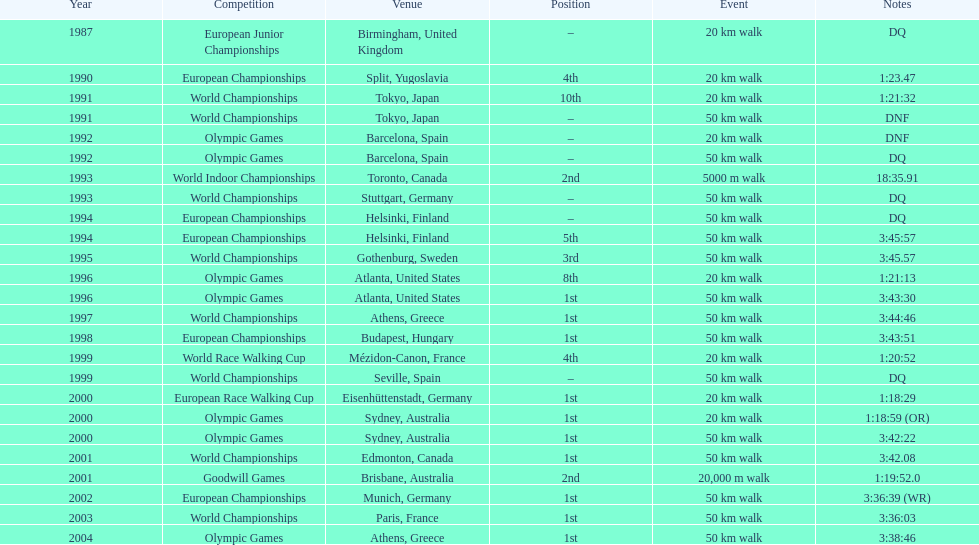Help me parse the entirety of this table. {'header': ['Year', 'Competition', 'Venue', 'Position', 'Event', 'Notes'], 'rows': [['1987', 'European Junior Championships', 'Birmingham, United Kingdom', '–', '20\xa0km walk', 'DQ'], ['1990', 'European Championships', 'Split, Yugoslavia', '4th', '20\xa0km walk', '1:23.47'], ['1991', 'World Championships', 'Tokyo, Japan', '10th', '20\xa0km walk', '1:21:32'], ['1991', 'World Championships', 'Tokyo, Japan', '–', '50\xa0km walk', 'DNF'], ['1992', 'Olympic Games', 'Barcelona, Spain', '–', '20\xa0km walk', 'DNF'], ['1992', 'Olympic Games', 'Barcelona, Spain', '–', '50\xa0km walk', 'DQ'], ['1993', 'World Indoor Championships', 'Toronto, Canada', '2nd', '5000 m walk', '18:35.91'], ['1993', 'World Championships', 'Stuttgart, Germany', '–', '50\xa0km walk', 'DQ'], ['1994', 'European Championships', 'Helsinki, Finland', '–', '50\xa0km walk', 'DQ'], ['1994', 'European Championships', 'Helsinki, Finland', '5th', '50\xa0km walk', '3:45:57'], ['1995', 'World Championships', 'Gothenburg, Sweden', '3rd', '50\xa0km walk', '3:45.57'], ['1996', 'Olympic Games', 'Atlanta, United States', '8th', '20\xa0km walk', '1:21:13'], ['1996', 'Olympic Games', 'Atlanta, United States', '1st', '50\xa0km walk', '3:43:30'], ['1997', 'World Championships', 'Athens, Greece', '1st', '50\xa0km walk', '3:44:46'], ['1998', 'European Championships', 'Budapest, Hungary', '1st', '50\xa0km walk', '3:43:51'], ['1999', 'World Race Walking Cup', 'Mézidon-Canon, France', '4th', '20\xa0km walk', '1:20:52'], ['1999', 'World Championships', 'Seville, Spain', '–', '50\xa0km walk', 'DQ'], ['2000', 'European Race Walking Cup', 'Eisenhüttenstadt, Germany', '1st', '20\xa0km walk', '1:18:29'], ['2000', 'Olympic Games', 'Sydney, Australia', '1st', '20\xa0km walk', '1:18:59 (OR)'], ['2000', 'Olympic Games', 'Sydney, Australia', '1st', '50\xa0km walk', '3:42:22'], ['2001', 'World Championships', 'Edmonton, Canada', '1st', '50\xa0km walk', '3:42.08'], ['2001', 'Goodwill Games', 'Brisbane, Australia', '2nd', '20,000 m walk', '1:19:52.0'], ['2002', 'European Championships', 'Munich, Germany', '1st', '50\xa0km walk', '3:36:39 (WR)'], ['2003', 'World Championships', 'Paris, France', '1st', '50\xa0km walk', '3:36:03'], ['2004', 'Olympic Games', 'Athens, Greece', '1st', '50\xa0km walk', '3:38:46']]} In how many occasions did korzeniowski end up in a position better than fourth place? 13. 